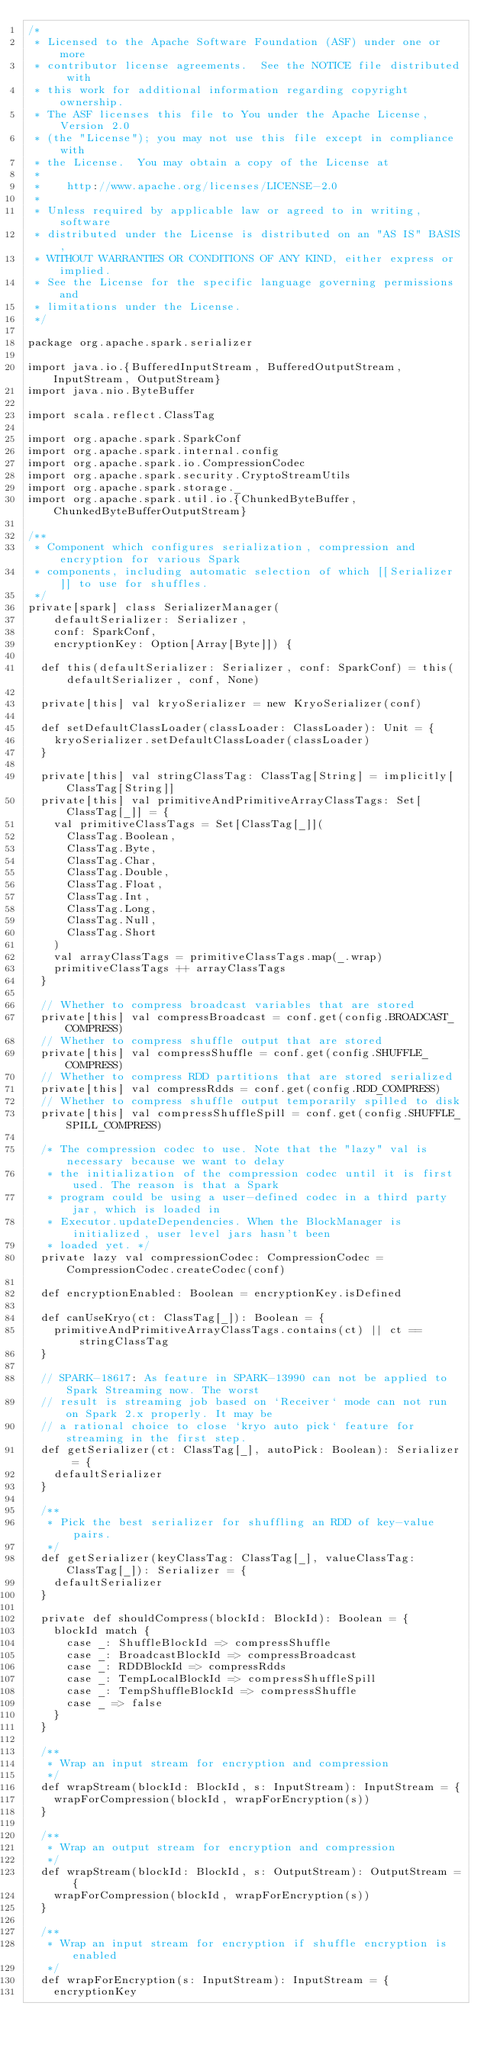Convert code to text. <code><loc_0><loc_0><loc_500><loc_500><_Scala_>/*
 * Licensed to the Apache Software Foundation (ASF) under one or more
 * contributor license agreements.  See the NOTICE file distributed with
 * this work for additional information regarding copyright ownership.
 * The ASF licenses this file to You under the Apache License, Version 2.0
 * (the "License"); you may not use this file except in compliance with
 * the License.  You may obtain a copy of the License at
 *
 *    http://www.apache.org/licenses/LICENSE-2.0
 *
 * Unless required by applicable law or agreed to in writing, software
 * distributed under the License is distributed on an "AS IS" BASIS,
 * WITHOUT WARRANTIES OR CONDITIONS OF ANY KIND, either express or implied.
 * See the License for the specific language governing permissions and
 * limitations under the License.
 */

package org.apache.spark.serializer

import java.io.{BufferedInputStream, BufferedOutputStream, InputStream, OutputStream}
import java.nio.ByteBuffer

import scala.reflect.ClassTag

import org.apache.spark.SparkConf
import org.apache.spark.internal.config
import org.apache.spark.io.CompressionCodec
import org.apache.spark.security.CryptoStreamUtils
import org.apache.spark.storage._
import org.apache.spark.util.io.{ChunkedByteBuffer, ChunkedByteBufferOutputStream}

/**
 * Component which configures serialization, compression and encryption for various Spark
 * components, including automatic selection of which [[Serializer]] to use for shuffles.
 */
private[spark] class SerializerManager(
    defaultSerializer: Serializer,
    conf: SparkConf,
    encryptionKey: Option[Array[Byte]]) {

  def this(defaultSerializer: Serializer, conf: SparkConf) = this(defaultSerializer, conf, None)

  private[this] val kryoSerializer = new KryoSerializer(conf)

  def setDefaultClassLoader(classLoader: ClassLoader): Unit = {
    kryoSerializer.setDefaultClassLoader(classLoader)
  }

  private[this] val stringClassTag: ClassTag[String] = implicitly[ClassTag[String]]
  private[this] val primitiveAndPrimitiveArrayClassTags: Set[ClassTag[_]] = {
    val primitiveClassTags = Set[ClassTag[_]](
      ClassTag.Boolean,
      ClassTag.Byte,
      ClassTag.Char,
      ClassTag.Double,
      ClassTag.Float,
      ClassTag.Int,
      ClassTag.Long,
      ClassTag.Null,
      ClassTag.Short
    )
    val arrayClassTags = primitiveClassTags.map(_.wrap)
    primitiveClassTags ++ arrayClassTags
  }

  // Whether to compress broadcast variables that are stored
  private[this] val compressBroadcast = conf.get(config.BROADCAST_COMPRESS)
  // Whether to compress shuffle output that are stored
  private[this] val compressShuffle = conf.get(config.SHUFFLE_COMPRESS)
  // Whether to compress RDD partitions that are stored serialized
  private[this] val compressRdds = conf.get(config.RDD_COMPRESS)
  // Whether to compress shuffle output temporarily spilled to disk
  private[this] val compressShuffleSpill = conf.get(config.SHUFFLE_SPILL_COMPRESS)

  /* The compression codec to use. Note that the "lazy" val is necessary because we want to delay
   * the initialization of the compression codec until it is first used. The reason is that a Spark
   * program could be using a user-defined codec in a third party jar, which is loaded in
   * Executor.updateDependencies. When the BlockManager is initialized, user level jars hasn't been
   * loaded yet. */
  private lazy val compressionCodec: CompressionCodec = CompressionCodec.createCodec(conf)

  def encryptionEnabled: Boolean = encryptionKey.isDefined

  def canUseKryo(ct: ClassTag[_]): Boolean = {
    primitiveAndPrimitiveArrayClassTags.contains(ct) || ct == stringClassTag
  }

  // SPARK-18617: As feature in SPARK-13990 can not be applied to Spark Streaming now. The worst
  // result is streaming job based on `Receiver` mode can not run on Spark 2.x properly. It may be
  // a rational choice to close `kryo auto pick` feature for streaming in the first step.
  def getSerializer(ct: ClassTag[_], autoPick: Boolean): Serializer = {
    defaultSerializer
  }

  /**
   * Pick the best serializer for shuffling an RDD of key-value pairs.
   */
  def getSerializer(keyClassTag: ClassTag[_], valueClassTag: ClassTag[_]): Serializer = {
    defaultSerializer
  }

  private def shouldCompress(blockId: BlockId): Boolean = {
    blockId match {
      case _: ShuffleBlockId => compressShuffle
      case _: BroadcastBlockId => compressBroadcast
      case _: RDDBlockId => compressRdds
      case _: TempLocalBlockId => compressShuffleSpill
      case _: TempShuffleBlockId => compressShuffle
      case _ => false
    }
  }

  /**
   * Wrap an input stream for encryption and compression
   */
  def wrapStream(blockId: BlockId, s: InputStream): InputStream = {
    wrapForCompression(blockId, wrapForEncryption(s))
  }

  /**
   * Wrap an output stream for encryption and compression
   */
  def wrapStream(blockId: BlockId, s: OutputStream): OutputStream = {
    wrapForCompression(blockId, wrapForEncryption(s))
  }

  /**
   * Wrap an input stream for encryption if shuffle encryption is enabled
   */
  def wrapForEncryption(s: InputStream): InputStream = {
    encryptionKey</code> 